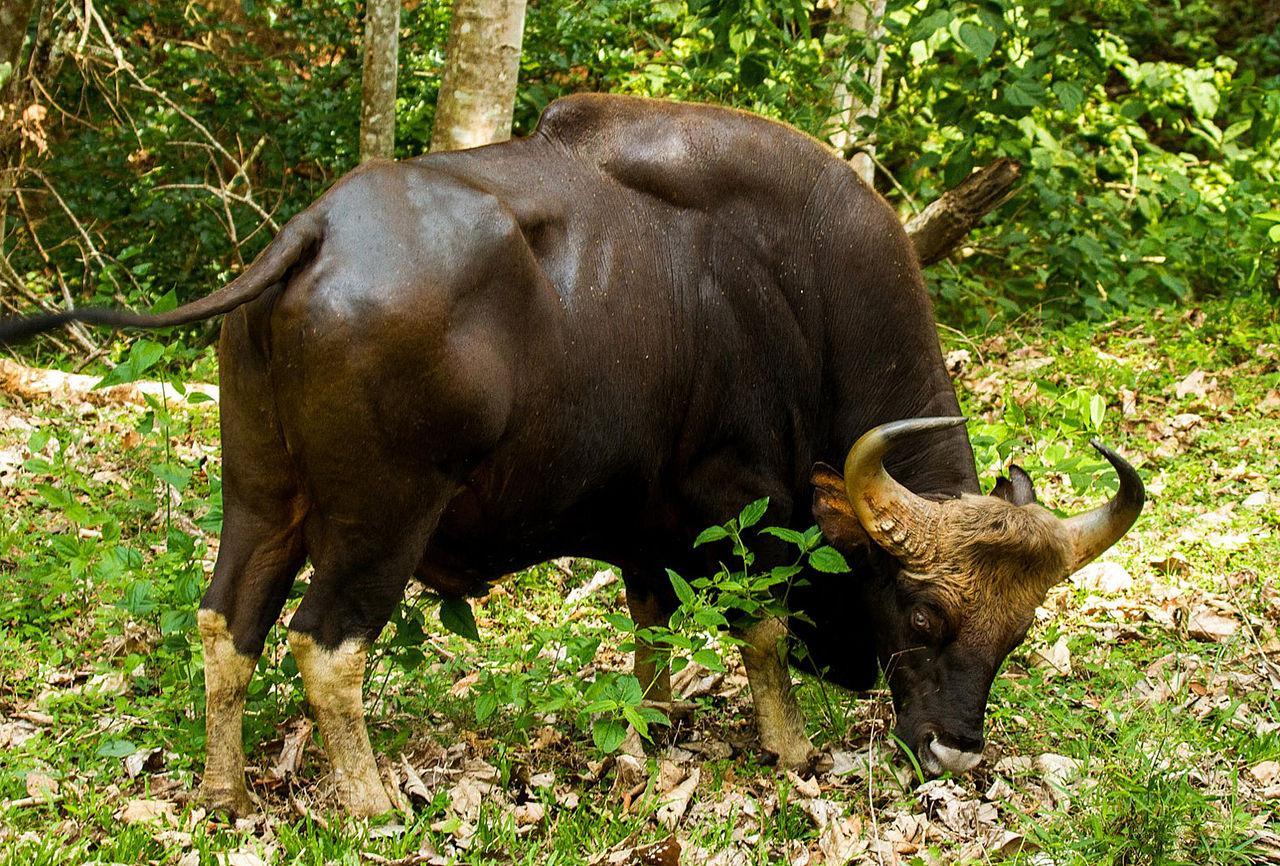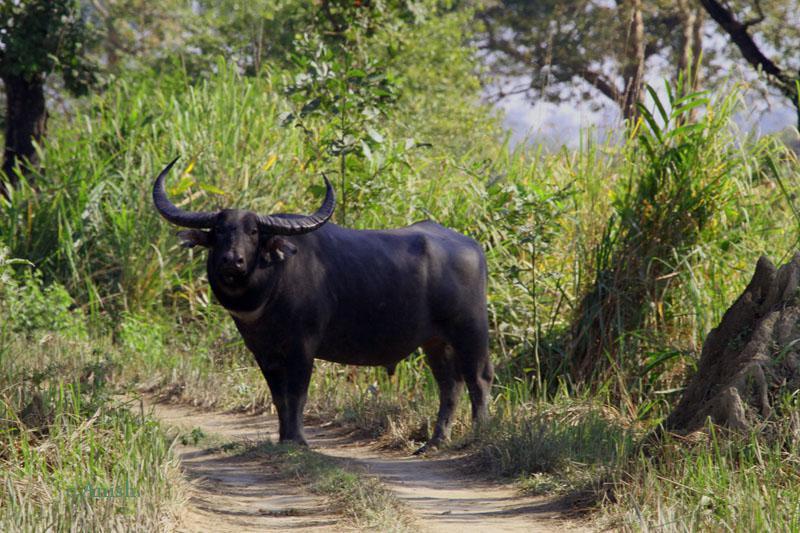The first image is the image on the left, the second image is the image on the right. Assess this claim about the two images: "There are three water buffalo's.". Correct or not? Answer yes or no. No. The first image is the image on the left, the second image is the image on the right. Evaluate the accuracy of this statement regarding the images: "A calf has its head and neck bent under a standing adult horned animal to nurse.". Is it true? Answer yes or no. No. 